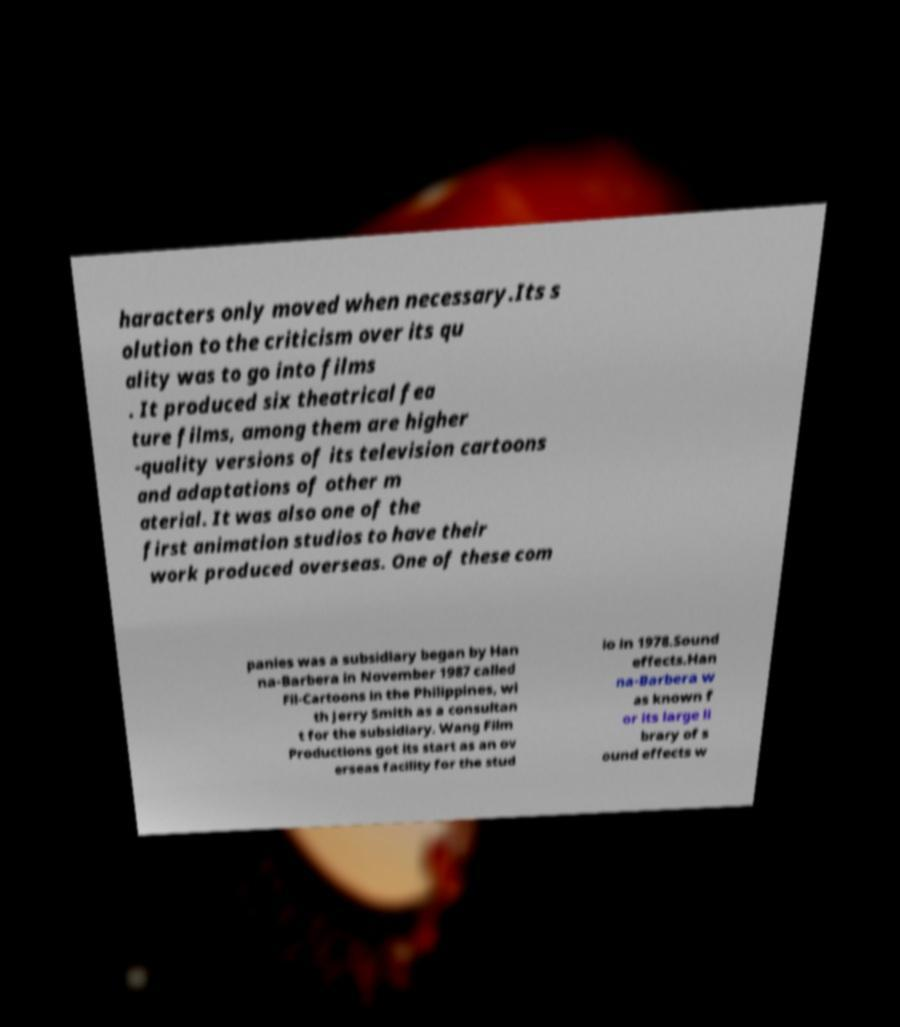There's text embedded in this image that I need extracted. Can you transcribe it verbatim? haracters only moved when necessary.Its s olution to the criticism over its qu ality was to go into films . It produced six theatrical fea ture films, among them are higher -quality versions of its television cartoons and adaptations of other m aterial. It was also one of the first animation studios to have their work produced overseas. One of these com panies was a subsidiary began by Han na-Barbera in November 1987 called Fil-Cartoons in the Philippines, wi th Jerry Smith as a consultan t for the subsidiary. Wang Film Productions got its start as an ov erseas facility for the stud io in 1978.Sound effects.Han na-Barbera w as known f or its large li brary of s ound effects w 